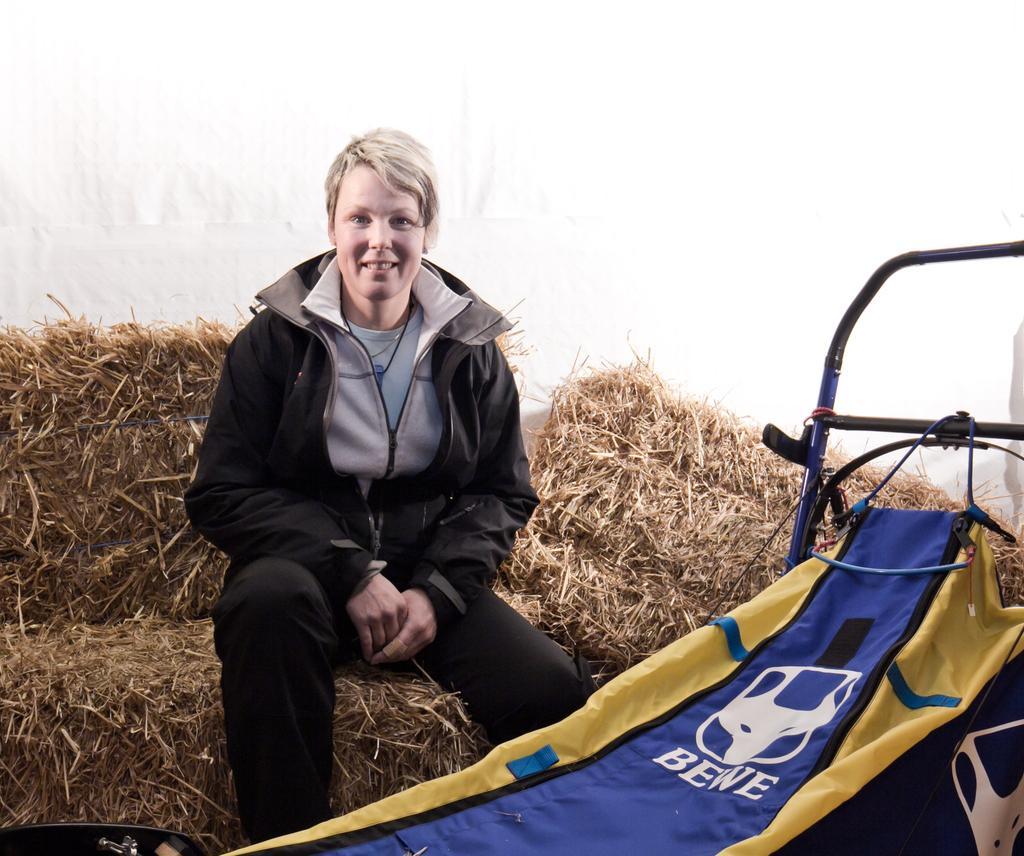Describe this image in one or two sentences. In this image I can see a person wearing white t shirt, black jacket and black pant is sitting on the grass. I can see a blue and yellow colored object. In the background I can see some grass and the white colored surface. 